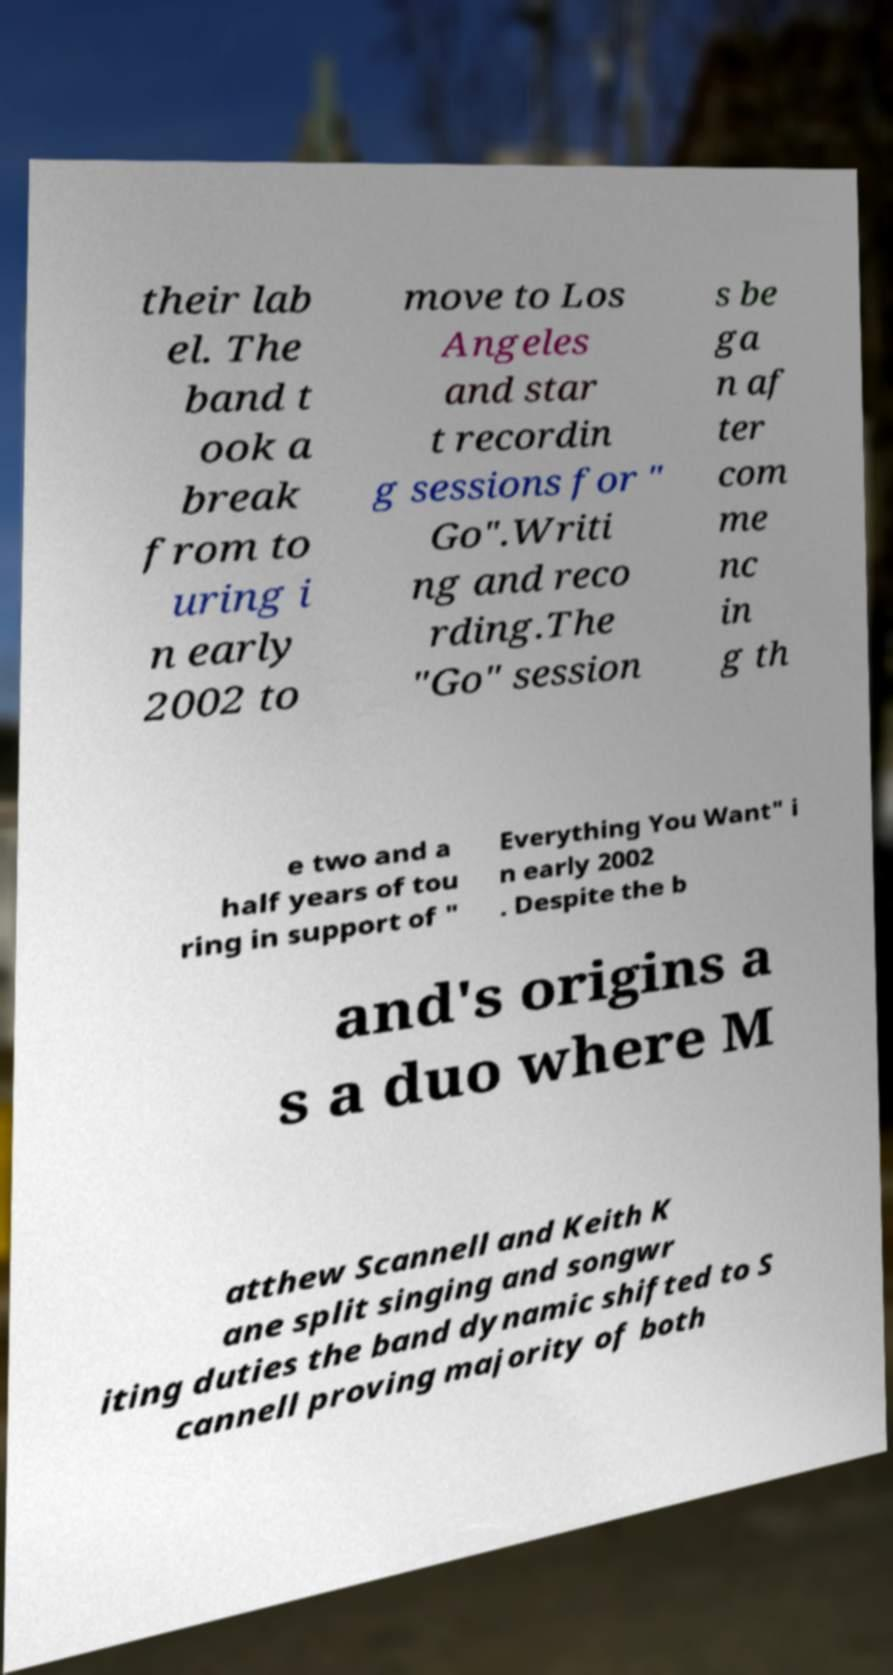I need the written content from this picture converted into text. Can you do that? their lab el. The band t ook a break from to uring i n early 2002 to move to Los Angeles and star t recordin g sessions for " Go".Writi ng and reco rding.The "Go" session s be ga n af ter com me nc in g th e two and a half years of tou ring in support of " Everything You Want" i n early 2002 . Despite the b and's origins a s a duo where M atthew Scannell and Keith K ane split singing and songwr iting duties the band dynamic shifted to S cannell proving majority of both 